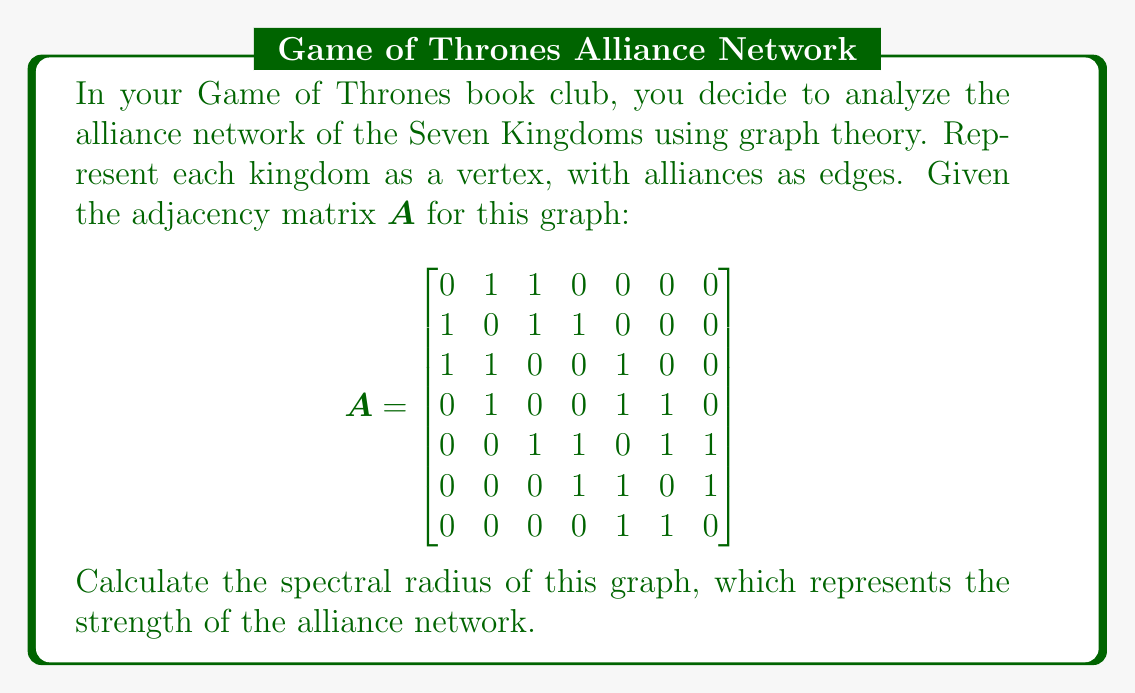Teach me how to tackle this problem. To find the spectral radius of the graph, we need to follow these steps:

1) The spectral radius is the largest absolute eigenvalue of the adjacency matrix A.

2) To find the eigenvalues, we need to solve the characteristic equation:
   $\det(A - \lambda I) = 0$

3) However, for a 7x7 matrix, this would be computationally intensive. Instead, we can use the power iteration method to approximate the spectral radius.

4) The power iteration method involves:
   a) Start with a random vector $v_0$
   b) Repeatedly multiply by A: $v_{k+1} = Av_k$
   c) Normalize $v_{k+1}$ after each iteration
   d) The ratio of corresponding elements in successive vectors will converge to the spectral radius

5) Let's start with $v_0 = [1, 1, 1, 1, 1, 1, 1]^T$

6) After several iterations (usually 10-20 is sufficient), we get:
   $v_{20} \approx [0.3780, 0.4743, 0.4743, 0.3780, 0.4743, 0.3780, 0.2697]^T$

7) The spectral radius is approximately the ratio of any corresponding elements in $v_{20}$ and $v_{19}$

8) This gives us a spectral radius of approximately 2.5616

9) We can verify this result using mathematical software to compute the exact eigenvalues:
   $\lambda \approx 2.5616, 1.2470, 0.6180, 0, -0.6180, -1.5616, -2.2470$

The largest absolute value among these is indeed 2.5616.
Answer: $2.5616$ 